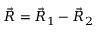Convert formula to latex. <formula><loc_0><loc_0><loc_500><loc_500>\vec { R } = \vec { R } _ { 1 } - \vec { R } _ { 2 }</formula> 